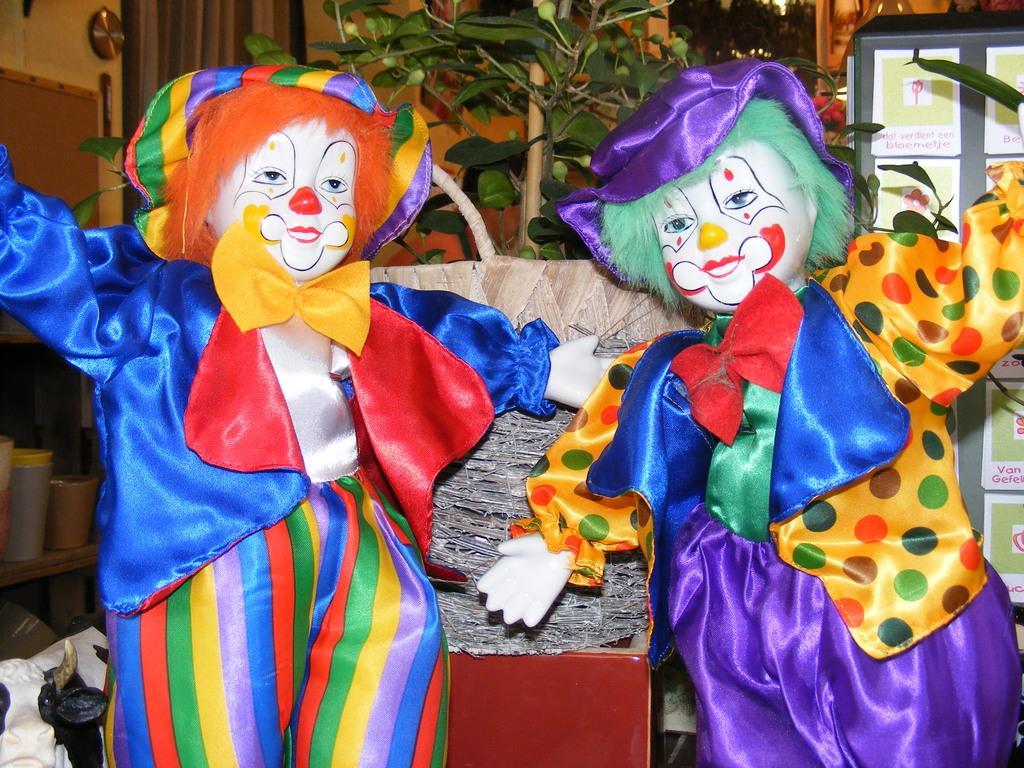Describe this image in one or two sentences. In this image we can see two toys. In the background we can see the plant, some board with text papers. We can also see the wall and some other objects placed on the wooden counter which is on the left. 